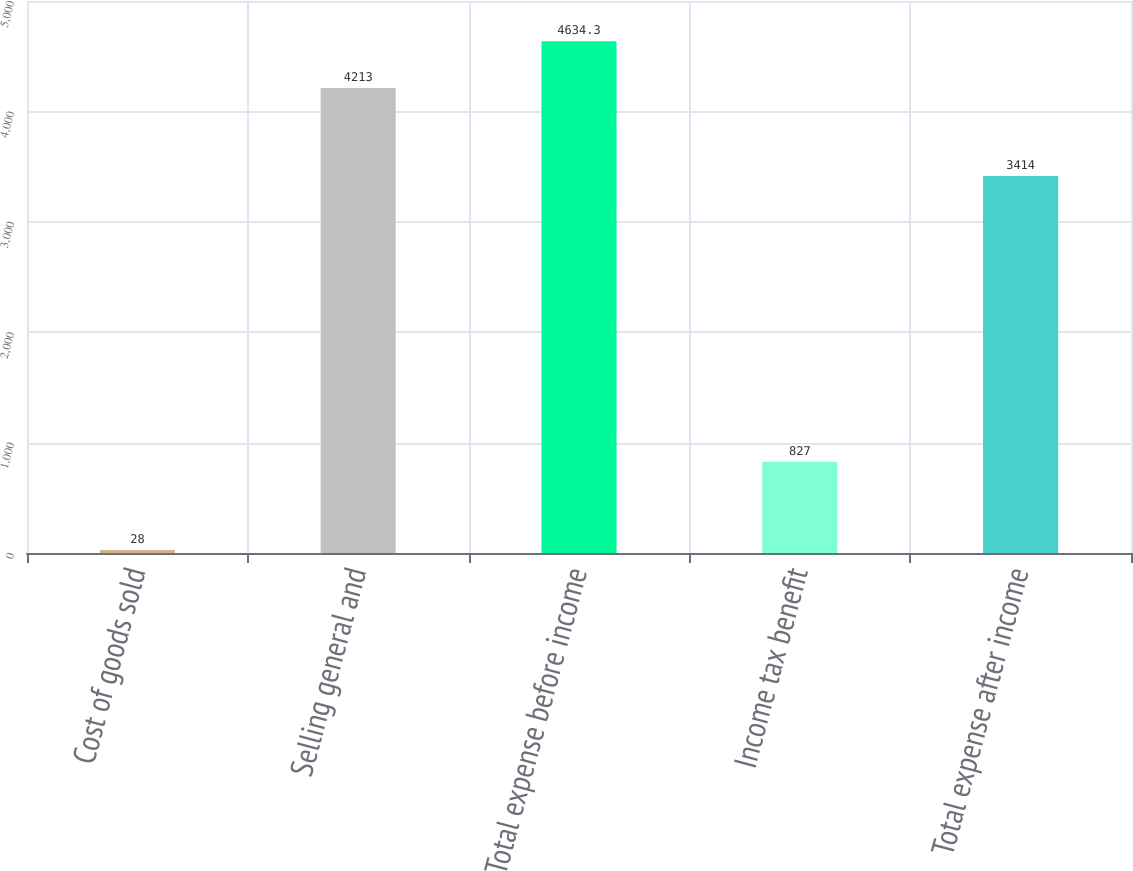Convert chart to OTSL. <chart><loc_0><loc_0><loc_500><loc_500><bar_chart><fcel>Cost of goods sold<fcel>Selling general and<fcel>Total expense before income<fcel>Income tax benefit<fcel>Total expense after income<nl><fcel>28<fcel>4213<fcel>4634.3<fcel>827<fcel>3414<nl></chart> 